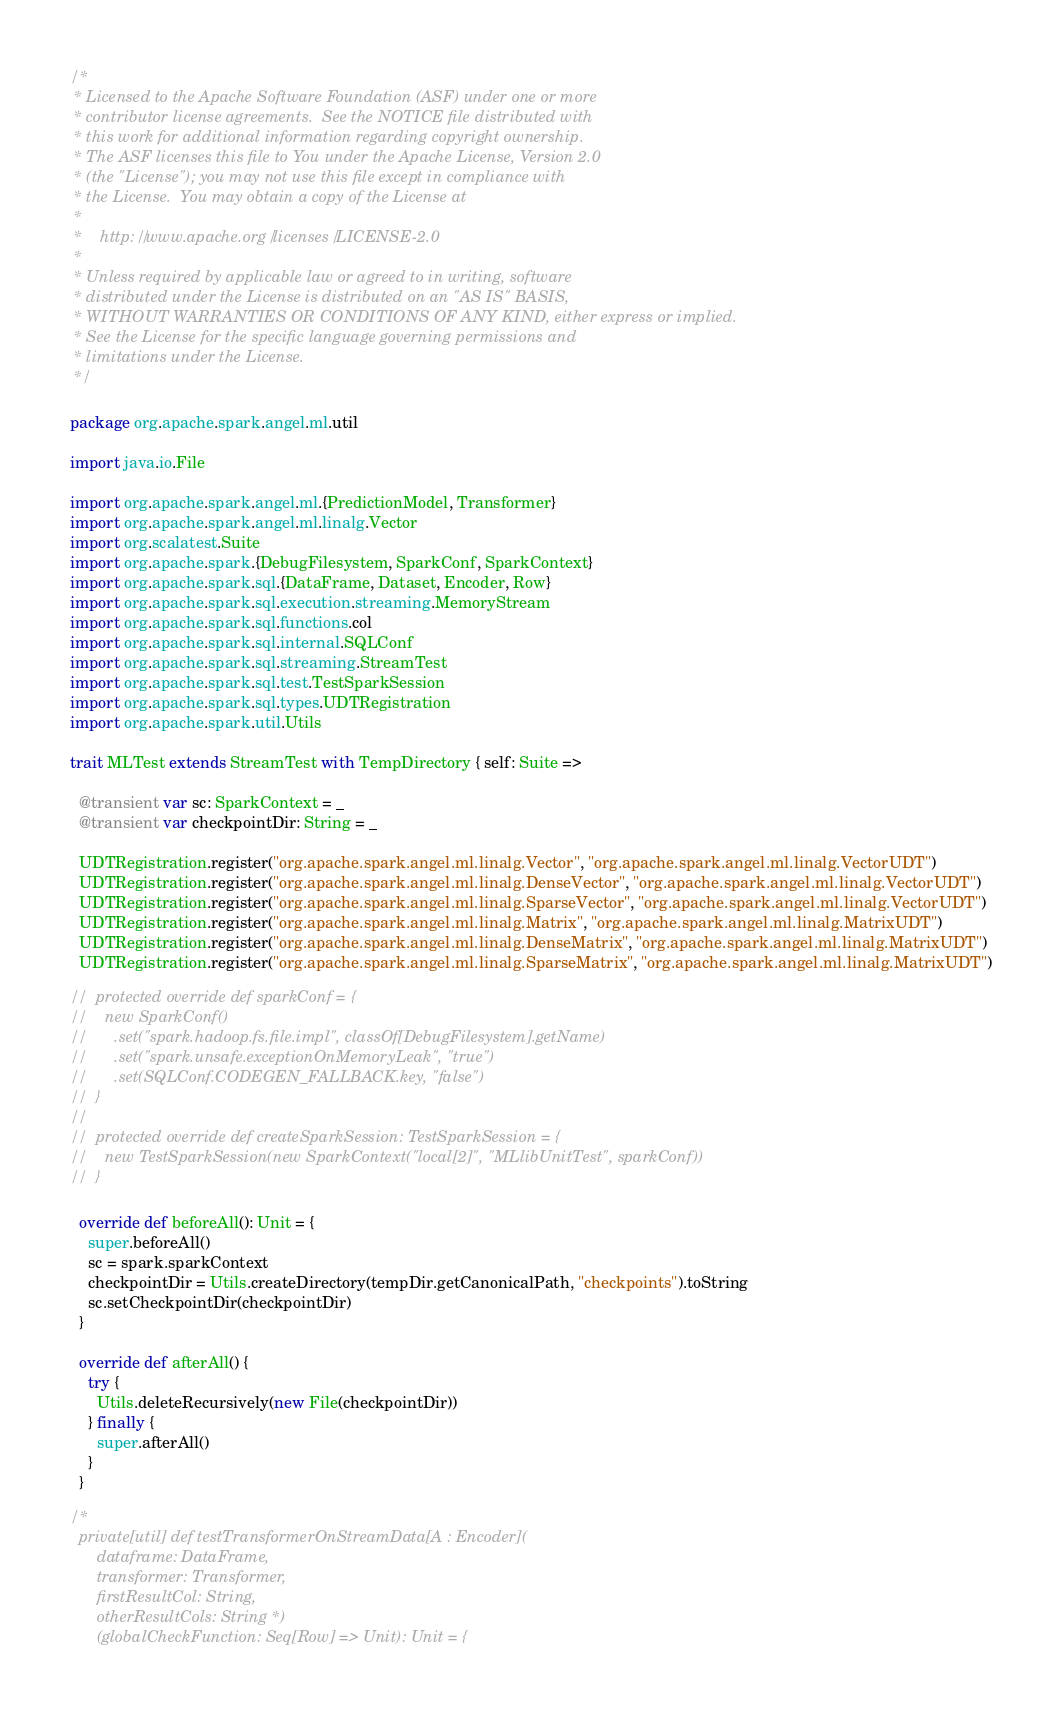<code> <loc_0><loc_0><loc_500><loc_500><_Scala_>/*
 * Licensed to the Apache Software Foundation (ASF) under one or more
 * contributor license agreements.  See the NOTICE file distributed with
 * this work for additional information regarding copyright ownership.
 * The ASF licenses this file to You under the Apache License, Version 2.0
 * (the "License"); you may not use this file except in compliance with
 * the License.  You may obtain a copy of the License at
 *
 *    http://www.apache.org/licenses/LICENSE-2.0
 *
 * Unless required by applicable law or agreed to in writing, software
 * distributed under the License is distributed on an "AS IS" BASIS,
 * WITHOUT WARRANTIES OR CONDITIONS OF ANY KIND, either express or implied.
 * See the License for the specific language governing permissions and
 * limitations under the License.
 */

package org.apache.spark.angel.ml.util

import java.io.File

import org.apache.spark.angel.ml.{PredictionModel, Transformer}
import org.apache.spark.angel.ml.linalg.Vector
import org.scalatest.Suite
import org.apache.spark.{DebugFilesystem, SparkConf, SparkContext}
import org.apache.spark.sql.{DataFrame, Dataset, Encoder, Row}
import org.apache.spark.sql.execution.streaming.MemoryStream
import org.apache.spark.sql.functions.col
import org.apache.spark.sql.internal.SQLConf
import org.apache.spark.sql.streaming.StreamTest
import org.apache.spark.sql.test.TestSparkSession
import org.apache.spark.sql.types.UDTRegistration
import org.apache.spark.util.Utils

trait MLTest extends StreamTest with TempDirectory { self: Suite =>

  @transient var sc: SparkContext = _
  @transient var checkpointDir: String = _

  UDTRegistration.register("org.apache.spark.angel.ml.linalg.Vector", "org.apache.spark.angel.ml.linalg.VectorUDT")
  UDTRegistration.register("org.apache.spark.angel.ml.linalg.DenseVector", "org.apache.spark.angel.ml.linalg.VectorUDT")
  UDTRegistration.register("org.apache.spark.angel.ml.linalg.SparseVector", "org.apache.spark.angel.ml.linalg.VectorUDT")
  UDTRegistration.register("org.apache.spark.angel.ml.linalg.Matrix", "org.apache.spark.angel.ml.linalg.MatrixUDT")
  UDTRegistration.register("org.apache.spark.angel.ml.linalg.DenseMatrix", "org.apache.spark.angel.ml.linalg.MatrixUDT")
  UDTRegistration.register("org.apache.spark.angel.ml.linalg.SparseMatrix", "org.apache.spark.angel.ml.linalg.MatrixUDT")

//  protected override def sparkConf = {
//    new SparkConf()
//      .set("spark.hadoop.fs.file.impl", classOf[DebugFilesystem].getName)
//      .set("spark.unsafe.exceptionOnMemoryLeak", "true")
//      .set(SQLConf.CODEGEN_FALLBACK.key, "false")
//  }
//
//  protected override def createSparkSession: TestSparkSession = {
//    new TestSparkSession(new SparkContext("local[2]", "MLlibUnitTest", sparkConf))
//  }

  override def beforeAll(): Unit = {
    super.beforeAll()
    sc = spark.sparkContext
    checkpointDir = Utils.createDirectory(tempDir.getCanonicalPath, "checkpoints").toString
    sc.setCheckpointDir(checkpointDir)
  }

  override def afterAll() {
    try {
      Utils.deleteRecursively(new File(checkpointDir))
    } finally {
      super.afterAll()
    }
  }

/*
  private[util] def testTransformerOnStreamData[A : Encoder](
      dataframe: DataFrame,
      transformer: Transformer,
      firstResultCol: String,
      otherResultCols: String*)
      (globalCheckFunction: Seq[Row] => Unit): Unit = {
</code> 